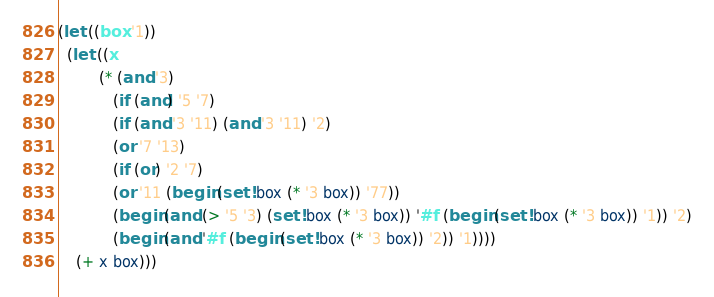Convert code to text. <code><loc_0><loc_0><loc_500><loc_500><_Scheme_>
(let ((box '1))
  (let ((x
         (* (and '3)
            (if (and) '5 '7)
            (if (and '3 '11) (and '3 '11) '2)
            (or '7 '13)
            (if (or) '2 '7)
            (or '11 (begin (set! box (* '3 box)) '77))
            (begin (and (> '5 '3) (set! box (* '3 box)) '#f (begin (set! box (* '3 box)) '1)) '2)
            (begin (and '#f (begin (set! box (* '3 box)) '2)) '1))))
    (+ x box)))
</code> 